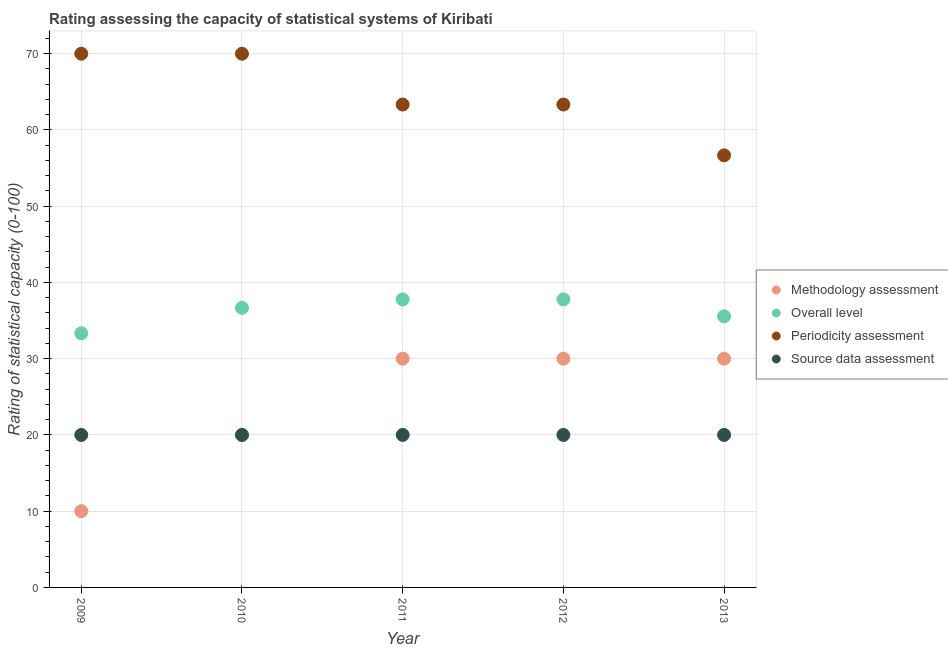Is the number of dotlines equal to the number of legend labels?
Your answer should be very brief. Yes. What is the periodicity assessment rating in 2013?
Keep it short and to the point. 56.67. Across all years, what is the maximum methodology assessment rating?
Your answer should be compact. 30. Across all years, what is the minimum overall level rating?
Ensure brevity in your answer.  33.33. In which year was the periodicity assessment rating maximum?
Offer a very short reply. 2009. In which year was the methodology assessment rating minimum?
Make the answer very short. 2009. What is the total overall level rating in the graph?
Keep it short and to the point. 181.11. What is the difference between the periodicity assessment rating in 2012 and that in 2013?
Give a very brief answer. 6.67. What is the difference between the periodicity assessment rating in 2011 and the source data assessment rating in 2009?
Offer a terse response. 43.33. What is the average periodicity assessment rating per year?
Your answer should be compact. 64.67. In the year 2013, what is the difference between the periodicity assessment rating and source data assessment rating?
Your answer should be compact. 36.67. Is the methodology assessment rating in 2012 less than that in 2013?
Provide a short and direct response. No. What is the difference between the highest and the second highest overall level rating?
Keep it short and to the point. 0. In how many years, is the periodicity assessment rating greater than the average periodicity assessment rating taken over all years?
Your response must be concise. 2. Is the sum of the periodicity assessment rating in 2010 and 2012 greater than the maximum overall level rating across all years?
Offer a terse response. Yes. Is it the case that in every year, the sum of the periodicity assessment rating and overall level rating is greater than the sum of source data assessment rating and methodology assessment rating?
Give a very brief answer. Yes. Does the source data assessment rating monotonically increase over the years?
Offer a very short reply. No. Is the source data assessment rating strictly greater than the periodicity assessment rating over the years?
Offer a very short reply. No. Is the source data assessment rating strictly less than the periodicity assessment rating over the years?
Offer a very short reply. Yes. How many dotlines are there?
Provide a short and direct response. 4. How are the legend labels stacked?
Make the answer very short. Vertical. What is the title of the graph?
Offer a very short reply. Rating assessing the capacity of statistical systems of Kiribati. Does "Argument" appear as one of the legend labels in the graph?
Make the answer very short. No. What is the label or title of the Y-axis?
Your answer should be compact. Rating of statistical capacity (0-100). What is the Rating of statistical capacity (0-100) of Methodology assessment in 2009?
Provide a short and direct response. 10. What is the Rating of statistical capacity (0-100) of Overall level in 2009?
Provide a short and direct response. 33.33. What is the Rating of statistical capacity (0-100) of Periodicity assessment in 2009?
Keep it short and to the point. 70. What is the Rating of statistical capacity (0-100) in Overall level in 2010?
Your answer should be compact. 36.67. What is the Rating of statistical capacity (0-100) of Overall level in 2011?
Your answer should be very brief. 37.78. What is the Rating of statistical capacity (0-100) in Periodicity assessment in 2011?
Give a very brief answer. 63.33. What is the Rating of statistical capacity (0-100) in Overall level in 2012?
Provide a short and direct response. 37.78. What is the Rating of statistical capacity (0-100) in Periodicity assessment in 2012?
Your answer should be compact. 63.33. What is the Rating of statistical capacity (0-100) in Overall level in 2013?
Provide a succinct answer. 35.56. What is the Rating of statistical capacity (0-100) in Periodicity assessment in 2013?
Offer a terse response. 56.67. Across all years, what is the maximum Rating of statistical capacity (0-100) in Overall level?
Offer a terse response. 37.78. Across all years, what is the maximum Rating of statistical capacity (0-100) in Source data assessment?
Your answer should be compact. 20. Across all years, what is the minimum Rating of statistical capacity (0-100) of Methodology assessment?
Provide a succinct answer. 10. Across all years, what is the minimum Rating of statistical capacity (0-100) of Overall level?
Keep it short and to the point. 33.33. Across all years, what is the minimum Rating of statistical capacity (0-100) in Periodicity assessment?
Give a very brief answer. 56.67. What is the total Rating of statistical capacity (0-100) of Methodology assessment in the graph?
Keep it short and to the point. 120. What is the total Rating of statistical capacity (0-100) of Overall level in the graph?
Keep it short and to the point. 181.11. What is the total Rating of statistical capacity (0-100) in Periodicity assessment in the graph?
Give a very brief answer. 323.33. What is the total Rating of statistical capacity (0-100) in Source data assessment in the graph?
Keep it short and to the point. 100. What is the difference between the Rating of statistical capacity (0-100) in Overall level in 2009 and that in 2010?
Your response must be concise. -3.33. What is the difference between the Rating of statistical capacity (0-100) in Periodicity assessment in 2009 and that in 2010?
Keep it short and to the point. 0. What is the difference between the Rating of statistical capacity (0-100) of Source data assessment in 2009 and that in 2010?
Your answer should be compact. 0. What is the difference between the Rating of statistical capacity (0-100) of Methodology assessment in 2009 and that in 2011?
Make the answer very short. -20. What is the difference between the Rating of statistical capacity (0-100) in Overall level in 2009 and that in 2011?
Offer a terse response. -4.44. What is the difference between the Rating of statistical capacity (0-100) of Methodology assessment in 2009 and that in 2012?
Offer a terse response. -20. What is the difference between the Rating of statistical capacity (0-100) of Overall level in 2009 and that in 2012?
Keep it short and to the point. -4.44. What is the difference between the Rating of statistical capacity (0-100) in Source data assessment in 2009 and that in 2012?
Give a very brief answer. 0. What is the difference between the Rating of statistical capacity (0-100) in Overall level in 2009 and that in 2013?
Offer a very short reply. -2.22. What is the difference between the Rating of statistical capacity (0-100) of Periodicity assessment in 2009 and that in 2013?
Provide a succinct answer. 13.33. What is the difference between the Rating of statistical capacity (0-100) in Source data assessment in 2009 and that in 2013?
Offer a terse response. 0. What is the difference between the Rating of statistical capacity (0-100) in Methodology assessment in 2010 and that in 2011?
Your response must be concise. -10. What is the difference between the Rating of statistical capacity (0-100) in Overall level in 2010 and that in 2011?
Give a very brief answer. -1.11. What is the difference between the Rating of statistical capacity (0-100) of Periodicity assessment in 2010 and that in 2011?
Your answer should be compact. 6.67. What is the difference between the Rating of statistical capacity (0-100) in Overall level in 2010 and that in 2012?
Offer a terse response. -1.11. What is the difference between the Rating of statistical capacity (0-100) in Source data assessment in 2010 and that in 2012?
Your response must be concise. 0. What is the difference between the Rating of statistical capacity (0-100) in Methodology assessment in 2010 and that in 2013?
Keep it short and to the point. -10. What is the difference between the Rating of statistical capacity (0-100) of Periodicity assessment in 2010 and that in 2013?
Your response must be concise. 13.33. What is the difference between the Rating of statistical capacity (0-100) of Source data assessment in 2010 and that in 2013?
Your answer should be very brief. 0. What is the difference between the Rating of statistical capacity (0-100) of Methodology assessment in 2011 and that in 2012?
Your answer should be very brief. 0. What is the difference between the Rating of statistical capacity (0-100) of Overall level in 2011 and that in 2012?
Offer a terse response. 0. What is the difference between the Rating of statistical capacity (0-100) in Periodicity assessment in 2011 and that in 2012?
Provide a short and direct response. 0. What is the difference between the Rating of statistical capacity (0-100) in Methodology assessment in 2011 and that in 2013?
Give a very brief answer. 0. What is the difference between the Rating of statistical capacity (0-100) of Overall level in 2011 and that in 2013?
Provide a succinct answer. 2.22. What is the difference between the Rating of statistical capacity (0-100) in Periodicity assessment in 2011 and that in 2013?
Your answer should be compact. 6.67. What is the difference between the Rating of statistical capacity (0-100) of Source data assessment in 2011 and that in 2013?
Keep it short and to the point. 0. What is the difference between the Rating of statistical capacity (0-100) in Methodology assessment in 2012 and that in 2013?
Give a very brief answer. 0. What is the difference between the Rating of statistical capacity (0-100) of Overall level in 2012 and that in 2013?
Your answer should be compact. 2.22. What is the difference between the Rating of statistical capacity (0-100) in Methodology assessment in 2009 and the Rating of statistical capacity (0-100) in Overall level in 2010?
Your answer should be very brief. -26.67. What is the difference between the Rating of statistical capacity (0-100) of Methodology assessment in 2009 and the Rating of statistical capacity (0-100) of Periodicity assessment in 2010?
Make the answer very short. -60. What is the difference between the Rating of statistical capacity (0-100) in Overall level in 2009 and the Rating of statistical capacity (0-100) in Periodicity assessment in 2010?
Ensure brevity in your answer.  -36.67. What is the difference between the Rating of statistical capacity (0-100) in Overall level in 2009 and the Rating of statistical capacity (0-100) in Source data assessment in 2010?
Offer a very short reply. 13.33. What is the difference between the Rating of statistical capacity (0-100) of Methodology assessment in 2009 and the Rating of statistical capacity (0-100) of Overall level in 2011?
Keep it short and to the point. -27.78. What is the difference between the Rating of statistical capacity (0-100) in Methodology assessment in 2009 and the Rating of statistical capacity (0-100) in Periodicity assessment in 2011?
Your response must be concise. -53.33. What is the difference between the Rating of statistical capacity (0-100) of Methodology assessment in 2009 and the Rating of statistical capacity (0-100) of Source data assessment in 2011?
Give a very brief answer. -10. What is the difference between the Rating of statistical capacity (0-100) in Overall level in 2009 and the Rating of statistical capacity (0-100) in Periodicity assessment in 2011?
Offer a very short reply. -30. What is the difference between the Rating of statistical capacity (0-100) of Overall level in 2009 and the Rating of statistical capacity (0-100) of Source data assessment in 2011?
Provide a short and direct response. 13.33. What is the difference between the Rating of statistical capacity (0-100) in Methodology assessment in 2009 and the Rating of statistical capacity (0-100) in Overall level in 2012?
Provide a succinct answer. -27.78. What is the difference between the Rating of statistical capacity (0-100) of Methodology assessment in 2009 and the Rating of statistical capacity (0-100) of Periodicity assessment in 2012?
Keep it short and to the point. -53.33. What is the difference between the Rating of statistical capacity (0-100) of Overall level in 2009 and the Rating of statistical capacity (0-100) of Source data assessment in 2012?
Provide a succinct answer. 13.33. What is the difference between the Rating of statistical capacity (0-100) of Methodology assessment in 2009 and the Rating of statistical capacity (0-100) of Overall level in 2013?
Offer a terse response. -25.56. What is the difference between the Rating of statistical capacity (0-100) in Methodology assessment in 2009 and the Rating of statistical capacity (0-100) in Periodicity assessment in 2013?
Your answer should be compact. -46.67. What is the difference between the Rating of statistical capacity (0-100) of Overall level in 2009 and the Rating of statistical capacity (0-100) of Periodicity assessment in 2013?
Your response must be concise. -23.33. What is the difference between the Rating of statistical capacity (0-100) of Overall level in 2009 and the Rating of statistical capacity (0-100) of Source data assessment in 2013?
Provide a short and direct response. 13.33. What is the difference between the Rating of statistical capacity (0-100) in Periodicity assessment in 2009 and the Rating of statistical capacity (0-100) in Source data assessment in 2013?
Offer a very short reply. 50. What is the difference between the Rating of statistical capacity (0-100) of Methodology assessment in 2010 and the Rating of statistical capacity (0-100) of Overall level in 2011?
Offer a very short reply. -17.78. What is the difference between the Rating of statistical capacity (0-100) in Methodology assessment in 2010 and the Rating of statistical capacity (0-100) in Periodicity assessment in 2011?
Offer a terse response. -43.33. What is the difference between the Rating of statistical capacity (0-100) in Methodology assessment in 2010 and the Rating of statistical capacity (0-100) in Source data assessment in 2011?
Your answer should be very brief. 0. What is the difference between the Rating of statistical capacity (0-100) in Overall level in 2010 and the Rating of statistical capacity (0-100) in Periodicity assessment in 2011?
Your answer should be very brief. -26.67. What is the difference between the Rating of statistical capacity (0-100) in Overall level in 2010 and the Rating of statistical capacity (0-100) in Source data assessment in 2011?
Make the answer very short. 16.67. What is the difference between the Rating of statistical capacity (0-100) of Methodology assessment in 2010 and the Rating of statistical capacity (0-100) of Overall level in 2012?
Keep it short and to the point. -17.78. What is the difference between the Rating of statistical capacity (0-100) of Methodology assessment in 2010 and the Rating of statistical capacity (0-100) of Periodicity assessment in 2012?
Make the answer very short. -43.33. What is the difference between the Rating of statistical capacity (0-100) of Methodology assessment in 2010 and the Rating of statistical capacity (0-100) of Source data assessment in 2012?
Your answer should be compact. 0. What is the difference between the Rating of statistical capacity (0-100) of Overall level in 2010 and the Rating of statistical capacity (0-100) of Periodicity assessment in 2012?
Your answer should be compact. -26.67. What is the difference between the Rating of statistical capacity (0-100) in Overall level in 2010 and the Rating of statistical capacity (0-100) in Source data assessment in 2012?
Provide a succinct answer. 16.67. What is the difference between the Rating of statistical capacity (0-100) in Methodology assessment in 2010 and the Rating of statistical capacity (0-100) in Overall level in 2013?
Provide a short and direct response. -15.56. What is the difference between the Rating of statistical capacity (0-100) in Methodology assessment in 2010 and the Rating of statistical capacity (0-100) in Periodicity assessment in 2013?
Offer a very short reply. -36.67. What is the difference between the Rating of statistical capacity (0-100) in Methodology assessment in 2010 and the Rating of statistical capacity (0-100) in Source data assessment in 2013?
Provide a short and direct response. 0. What is the difference between the Rating of statistical capacity (0-100) in Overall level in 2010 and the Rating of statistical capacity (0-100) in Periodicity assessment in 2013?
Give a very brief answer. -20. What is the difference between the Rating of statistical capacity (0-100) in Overall level in 2010 and the Rating of statistical capacity (0-100) in Source data assessment in 2013?
Your response must be concise. 16.67. What is the difference between the Rating of statistical capacity (0-100) in Methodology assessment in 2011 and the Rating of statistical capacity (0-100) in Overall level in 2012?
Your answer should be very brief. -7.78. What is the difference between the Rating of statistical capacity (0-100) in Methodology assessment in 2011 and the Rating of statistical capacity (0-100) in Periodicity assessment in 2012?
Offer a very short reply. -33.33. What is the difference between the Rating of statistical capacity (0-100) in Methodology assessment in 2011 and the Rating of statistical capacity (0-100) in Source data assessment in 2012?
Offer a very short reply. 10. What is the difference between the Rating of statistical capacity (0-100) of Overall level in 2011 and the Rating of statistical capacity (0-100) of Periodicity assessment in 2012?
Provide a short and direct response. -25.56. What is the difference between the Rating of statistical capacity (0-100) of Overall level in 2011 and the Rating of statistical capacity (0-100) of Source data assessment in 2012?
Ensure brevity in your answer.  17.78. What is the difference between the Rating of statistical capacity (0-100) of Periodicity assessment in 2011 and the Rating of statistical capacity (0-100) of Source data assessment in 2012?
Offer a very short reply. 43.33. What is the difference between the Rating of statistical capacity (0-100) of Methodology assessment in 2011 and the Rating of statistical capacity (0-100) of Overall level in 2013?
Ensure brevity in your answer.  -5.56. What is the difference between the Rating of statistical capacity (0-100) in Methodology assessment in 2011 and the Rating of statistical capacity (0-100) in Periodicity assessment in 2013?
Your response must be concise. -26.67. What is the difference between the Rating of statistical capacity (0-100) of Overall level in 2011 and the Rating of statistical capacity (0-100) of Periodicity assessment in 2013?
Provide a succinct answer. -18.89. What is the difference between the Rating of statistical capacity (0-100) of Overall level in 2011 and the Rating of statistical capacity (0-100) of Source data assessment in 2013?
Your answer should be very brief. 17.78. What is the difference between the Rating of statistical capacity (0-100) of Periodicity assessment in 2011 and the Rating of statistical capacity (0-100) of Source data assessment in 2013?
Offer a terse response. 43.33. What is the difference between the Rating of statistical capacity (0-100) of Methodology assessment in 2012 and the Rating of statistical capacity (0-100) of Overall level in 2013?
Your response must be concise. -5.56. What is the difference between the Rating of statistical capacity (0-100) of Methodology assessment in 2012 and the Rating of statistical capacity (0-100) of Periodicity assessment in 2013?
Your answer should be compact. -26.67. What is the difference between the Rating of statistical capacity (0-100) of Methodology assessment in 2012 and the Rating of statistical capacity (0-100) of Source data assessment in 2013?
Provide a short and direct response. 10. What is the difference between the Rating of statistical capacity (0-100) in Overall level in 2012 and the Rating of statistical capacity (0-100) in Periodicity assessment in 2013?
Offer a terse response. -18.89. What is the difference between the Rating of statistical capacity (0-100) in Overall level in 2012 and the Rating of statistical capacity (0-100) in Source data assessment in 2013?
Your answer should be very brief. 17.78. What is the difference between the Rating of statistical capacity (0-100) of Periodicity assessment in 2012 and the Rating of statistical capacity (0-100) of Source data assessment in 2013?
Keep it short and to the point. 43.33. What is the average Rating of statistical capacity (0-100) of Methodology assessment per year?
Provide a short and direct response. 24. What is the average Rating of statistical capacity (0-100) in Overall level per year?
Provide a short and direct response. 36.22. What is the average Rating of statistical capacity (0-100) of Periodicity assessment per year?
Keep it short and to the point. 64.67. In the year 2009, what is the difference between the Rating of statistical capacity (0-100) of Methodology assessment and Rating of statistical capacity (0-100) of Overall level?
Provide a succinct answer. -23.33. In the year 2009, what is the difference between the Rating of statistical capacity (0-100) of Methodology assessment and Rating of statistical capacity (0-100) of Periodicity assessment?
Provide a succinct answer. -60. In the year 2009, what is the difference between the Rating of statistical capacity (0-100) in Methodology assessment and Rating of statistical capacity (0-100) in Source data assessment?
Offer a very short reply. -10. In the year 2009, what is the difference between the Rating of statistical capacity (0-100) of Overall level and Rating of statistical capacity (0-100) of Periodicity assessment?
Provide a succinct answer. -36.67. In the year 2009, what is the difference between the Rating of statistical capacity (0-100) in Overall level and Rating of statistical capacity (0-100) in Source data assessment?
Your answer should be compact. 13.33. In the year 2010, what is the difference between the Rating of statistical capacity (0-100) in Methodology assessment and Rating of statistical capacity (0-100) in Overall level?
Keep it short and to the point. -16.67. In the year 2010, what is the difference between the Rating of statistical capacity (0-100) in Overall level and Rating of statistical capacity (0-100) in Periodicity assessment?
Your response must be concise. -33.33. In the year 2010, what is the difference between the Rating of statistical capacity (0-100) of Overall level and Rating of statistical capacity (0-100) of Source data assessment?
Offer a very short reply. 16.67. In the year 2010, what is the difference between the Rating of statistical capacity (0-100) of Periodicity assessment and Rating of statistical capacity (0-100) of Source data assessment?
Provide a succinct answer. 50. In the year 2011, what is the difference between the Rating of statistical capacity (0-100) of Methodology assessment and Rating of statistical capacity (0-100) of Overall level?
Make the answer very short. -7.78. In the year 2011, what is the difference between the Rating of statistical capacity (0-100) of Methodology assessment and Rating of statistical capacity (0-100) of Periodicity assessment?
Your answer should be compact. -33.33. In the year 2011, what is the difference between the Rating of statistical capacity (0-100) in Overall level and Rating of statistical capacity (0-100) in Periodicity assessment?
Ensure brevity in your answer.  -25.56. In the year 2011, what is the difference between the Rating of statistical capacity (0-100) in Overall level and Rating of statistical capacity (0-100) in Source data assessment?
Keep it short and to the point. 17.78. In the year 2011, what is the difference between the Rating of statistical capacity (0-100) of Periodicity assessment and Rating of statistical capacity (0-100) of Source data assessment?
Keep it short and to the point. 43.33. In the year 2012, what is the difference between the Rating of statistical capacity (0-100) of Methodology assessment and Rating of statistical capacity (0-100) of Overall level?
Provide a short and direct response. -7.78. In the year 2012, what is the difference between the Rating of statistical capacity (0-100) in Methodology assessment and Rating of statistical capacity (0-100) in Periodicity assessment?
Your answer should be very brief. -33.33. In the year 2012, what is the difference between the Rating of statistical capacity (0-100) of Overall level and Rating of statistical capacity (0-100) of Periodicity assessment?
Give a very brief answer. -25.56. In the year 2012, what is the difference between the Rating of statistical capacity (0-100) in Overall level and Rating of statistical capacity (0-100) in Source data assessment?
Provide a succinct answer. 17.78. In the year 2012, what is the difference between the Rating of statistical capacity (0-100) of Periodicity assessment and Rating of statistical capacity (0-100) of Source data assessment?
Offer a very short reply. 43.33. In the year 2013, what is the difference between the Rating of statistical capacity (0-100) in Methodology assessment and Rating of statistical capacity (0-100) in Overall level?
Give a very brief answer. -5.56. In the year 2013, what is the difference between the Rating of statistical capacity (0-100) in Methodology assessment and Rating of statistical capacity (0-100) in Periodicity assessment?
Give a very brief answer. -26.67. In the year 2013, what is the difference between the Rating of statistical capacity (0-100) in Methodology assessment and Rating of statistical capacity (0-100) in Source data assessment?
Your answer should be very brief. 10. In the year 2013, what is the difference between the Rating of statistical capacity (0-100) in Overall level and Rating of statistical capacity (0-100) in Periodicity assessment?
Your answer should be compact. -21.11. In the year 2013, what is the difference between the Rating of statistical capacity (0-100) in Overall level and Rating of statistical capacity (0-100) in Source data assessment?
Ensure brevity in your answer.  15.56. In the year 2013, what is the difference between the Rating of statistical capacity (0-100) of Periodicity assessment and Rating of statistical capacity (0-100) of Source data assessment?
Make the answer very short. 36.67. What is the ratio of the Rating of statistical capacity (0-100) in Overall level in 2009 to that in 2011?
Make the answer very short. 0.88. What is the ratio of the Rating of statistical capacity (0-100) in Periodicity assessment in 2009 to that in 2011?
Offer a very short reply. 1.11. What is the ratio of the Rating of statistical capacity (0-100) of Overall level in 2009 to that in 2012?
Keep it short and to the point. 0.88. What is the ratio of the Rating of statistical capacity (0-100) of Periodicity assessment in 2009 to that in 2012?
Give a very brief answer. 1.11. What is the ratio of the Rating of statistical capacity (0-100) in Source data assessment in 2009 to that in 2012?
Give a very brief answer. 1. What is the ratio of the Rating of statistical capacity (0-100) of Methodology assessment in 2009 to that in 2013?
Make the answer very short. 0.33. What is the ratio of the Rating of statistical capacity (0-100) of Periodicity assessment in 2009 to that in 2013?
Your answer should be very brief. 1.24. What is the ratio of the Rating of statistical capacity (0-100) of Source data assessment in 2009 to that in 2013?
Provide a short and direct response. 1. What is the ratio of the Rating of statistical capacity (0-100) in Overall level in 2010 to that in 2011?
Your answer should be very brief. 0.97. What is the ratio of the Rating of statistical capacity (0-100) of Periodicity assessment in 2010 to that in 2011?
Ensure brevity in your answer.  1.11. What is the ratio of the Rating of statistical capacity (0-100) in Source data assessment in 2010 to that in 2011?
Give a very brief answer. 1. What is the ratio of the Rating of statistical capacity (0-100) of Overall level in 2010 to that in 2012?
Your answer should be compact. 0.97. What is the ratio of the Rating of statistical capacity (0-100) in Periodicity assessment in 2010 to that in 2012?
Offer a terse response. 1.11. What is the ratio of the Rating of statistical capacity (0-100) of Overall level in 2010 to that in 2013?
Ensure brevity in your answer.  1.03. What is the ratio of the Rating of statistical capacity (0-100) of Periodicity assessment in 2010 to that in 2013?
Keep it short and to the point. 1.24. What is the ratio of the Rating of statistical capacity (0-100) of Source data assessment in 2010 to that in 2013?
Offer a very short reply. 1. What is the ratio of the Rating of statistical capacity (0-100) of Periodicity assessment in 2011 to that in 2012?
Provide a short and direct response. 1. What is the ratio of the Rating of statistical capacity (0-100) of Overall level in 2011 to that in 2013?
Ensure brevity in your answer.  1.06. What is the ratio of the Rating of statistical capacity (0-100) in Periodicity assessment in 2011 to that in 2013?
Give a very brief answer. 1.12. What is the ratio of the Rating of statistical capacity (0-100) in Methodology assessment in 2012 to that in 2013?
Your answer should be compact. 1. What is the ratio of the Rating of statistical capacity (0-100) in Periodicity assessment in 2012 to that in 2013?
Ensure brevity in your answer.  1.12. What is the difference between the highest and the second highest Rating of statistical capacity (0-100) of Methodology assessment?
Offer a terse response. 0. What is the difference between the highest and the lowest Rating of statistical capacity (0-100) of Overall level?
Provide a succinct answer. 4.44. What is the difference between the highest and the lowest Rating of statistical capacity (0-100) in Periodicity assessment?
Your response must be concise. 13.33. 